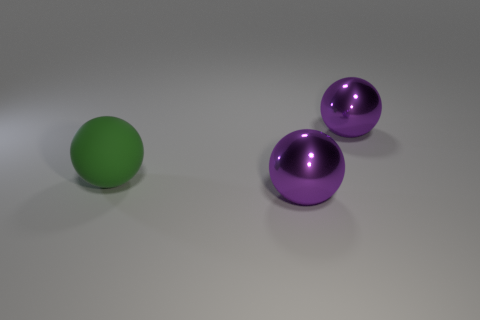What shapes are the objects in the image? The shapes in the image include a green sphere and two purple spheroids. Could you explain what a spheroid is? Certainly! A spheroid is an object that is similar to a sphere but often elongated or flattened, making it more oval than a perfect sphere. Are the purple objects perfect spheroids? From the image, the purple objects appear to be perfect spheroids without noticeable distortion or irregularities. 